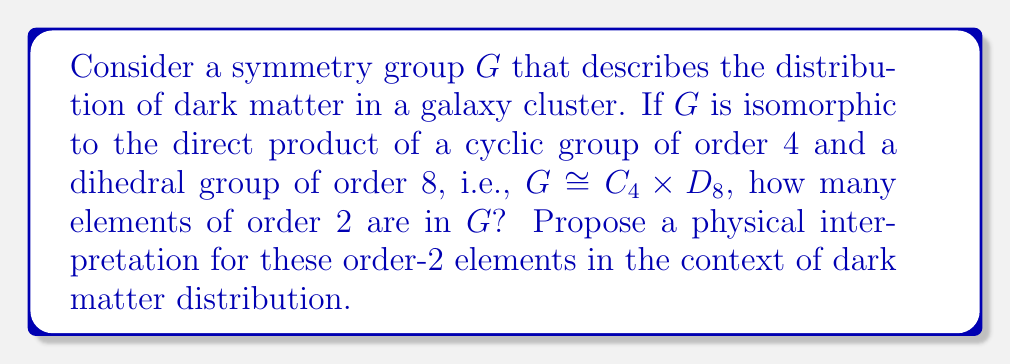Show me your answer to this math problem. To solve this problem, we'll follow these steps:

1) First, recall that $|G| = |C_4 \times D_8| = |C_4| \cdot |D_8| = 4 \cdot 8 = 32$.

2) In $C_4$, there is only one element of order 2, namely $c^2$ where $c$ is a generator of $C_4$.

3) In $D_8$, there are 5 elements of order 2: the rotation by 180° and all 4 reflections.

4) In the direct product $G = C_4 \times D_8$, elements of order 2 can come from three sources:
   a) $(e, d)$ where $e$ is the identity in $C_4$ and $d$ is an order-2 element in $D_8$
   b) $(c^2, e)$ where $c^2$ is the order-2 element in $C_4$ and $e$ is the identity in $D_8$
   c) $(c^2, d)$ where both components are order-2 elements

5) Counting these:
   a) There are 5 elements of the form $(e, d)$
   b) There is 1 element of the form $(c^2, e)$
   c) There are 5 elements of the form $(c^2, d)$

6) In total, there are $5 + 1 + 5 = 11$ elements of order 2 in $G$.

Physical interpretation: In the context of dark matter distribution, elements of order 2 could represent symmetries that, when applied twice, return the distribution to its original state. For example:

- Reflections across a plane (e.g., galactic plane)
- 180° rotations around an axis
- Combinations of these operations

The presence of 11 such elements suggests a rich symmetry structure in the dark matter distribution, potentially indicating:

- Multiple planes of symmetry in the cluster
- Several axes of 180° rotational symmetry
- Combinations of these symmetries that interact in complex ways

This symmetry structure could provide insights into the formation history of the cluster, the interaction between dark matter and visible matter, or constraints on the properties of dark matter particles themselves.
Answer: There are 11 elements of order 2 in $G \cong C_4 \times D_8$. 